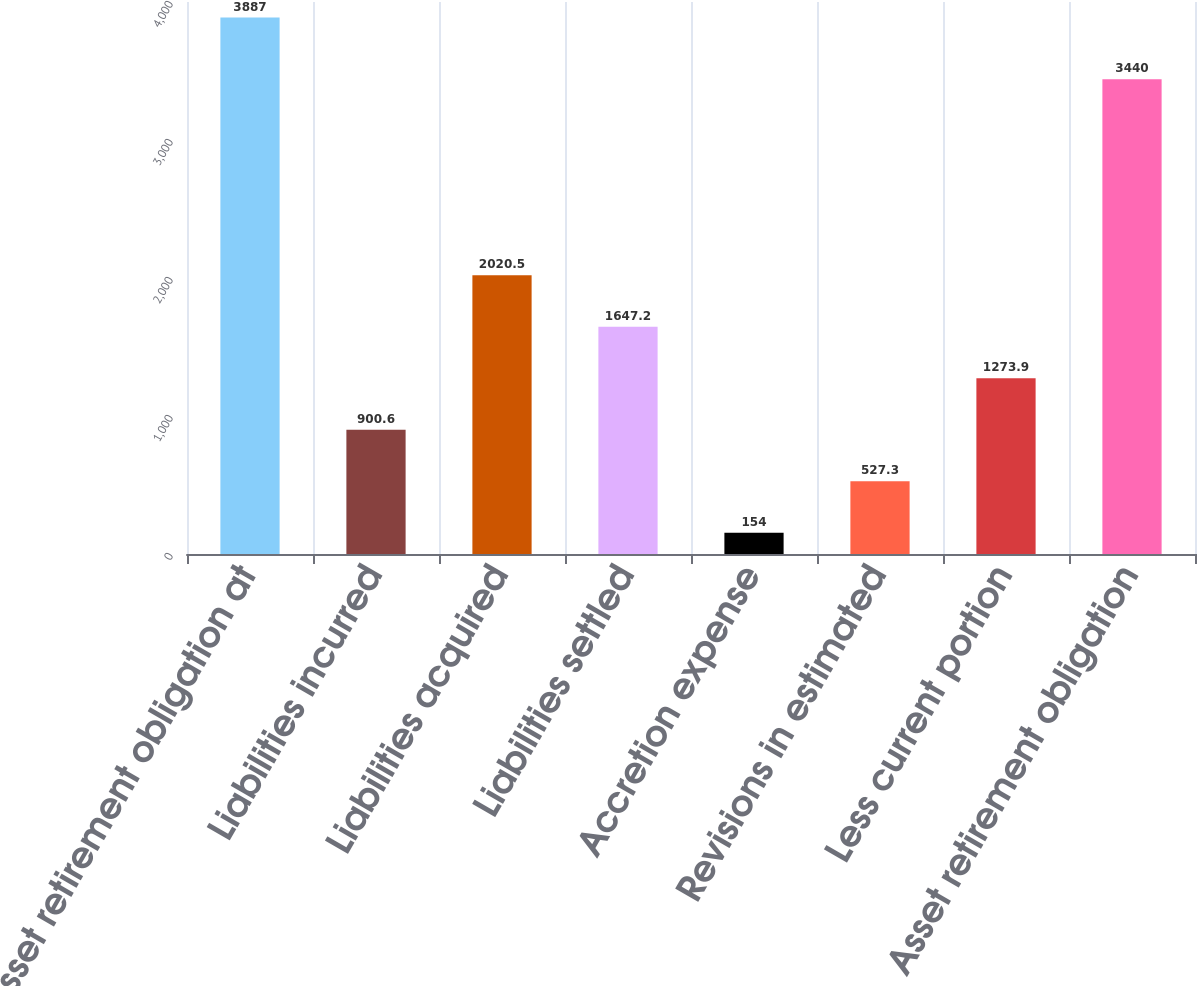Convert chart. <chart><loc_0><loc_0><loc_500><loc_500><bar_chart><fcel>Asset retirement obligation at<fcel>Liabilities incurred<fcel>Liabilities acquired<fcel>Liabilities settled<fcel>Accretion expense<fcel>Revisions in estimated<fcel>Less current portion<fcel>Asset retirement obligation<nl><fcel>3887<fcel>900.6<fcel>2020.5<fcel>1647.2<fcel>154<fcel>527.3<fcel>1273.9<fcel>3440<nl></chart> 